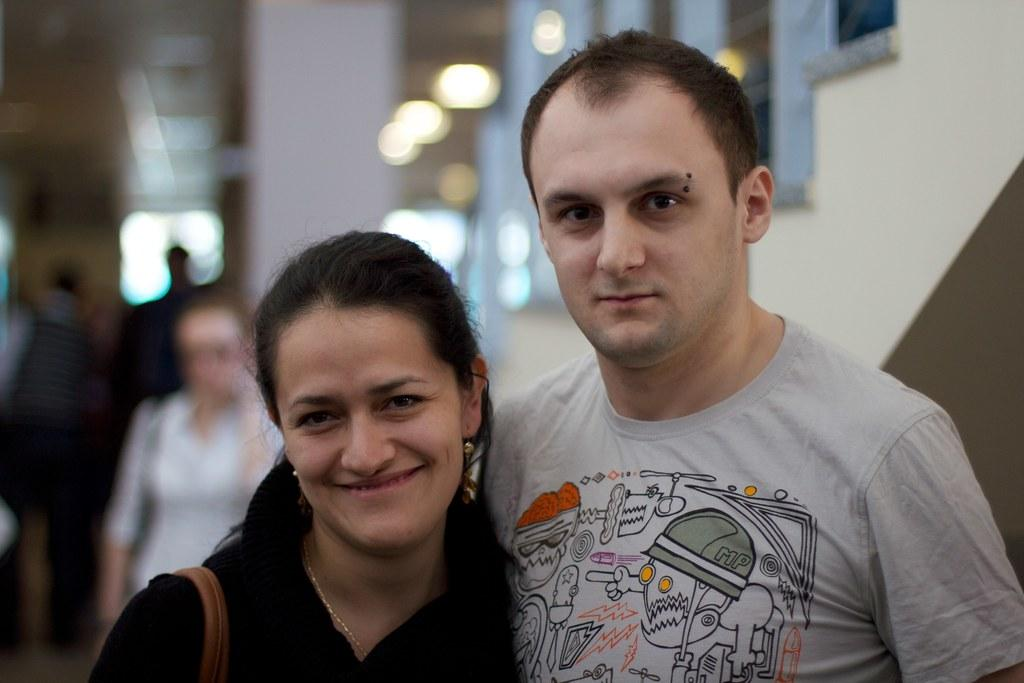How many people are present in the image? There are two people in the image, a man and a woman. What are the people in the image doing? The facts provided do not specify what the people are doing, but they are standing in the image. Can you describe the background of the image? The background of the image is blurred. What type of cap is the man wearing in the image? There is no cap visible in the image. What dish is the woman preparing with a knife in the image? There is no knife or dish preparation present in the image. 